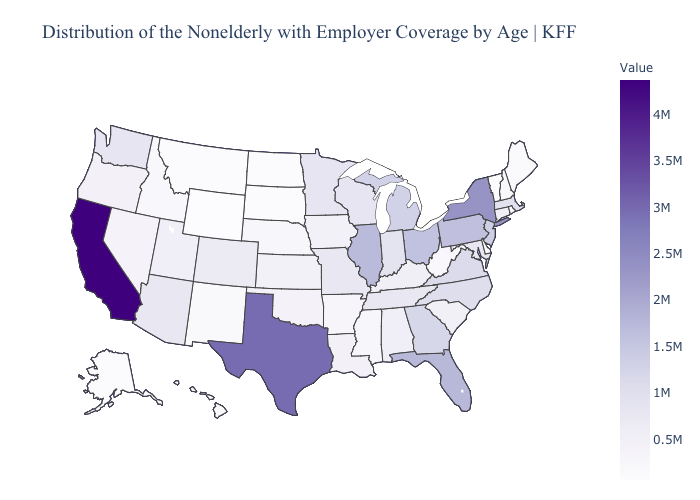Does California have the highest value in the USA?
Concise answer only. Yes. Does Maryland have the highest value in the South?
Write a very short answer. No. Which states have the lowest value in the MidWest?
Answer briefly. North Dakota. Does California have the highest value in the West?
Concise answer only. Yes. Does Alabama have a higher value than North Dakota?
Be succinct. Yes. 